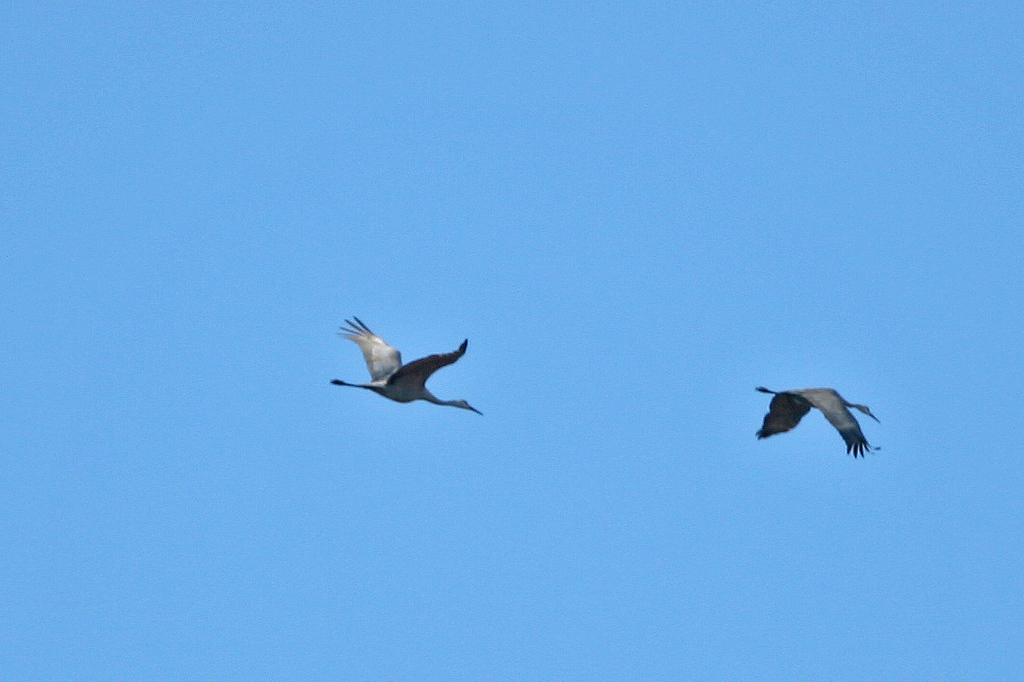How many birds are visible in the image? There are two birds in the image. What are the birds doing in the image? The birds are flying in the sky. What type of basin can be seen in the image? There is no basin present in the image; it features two birds flying in the sky. Can you tell me how many geese are flying in the image? The image does not depict geese; it features two birds, but their specific species is not mentioned. 